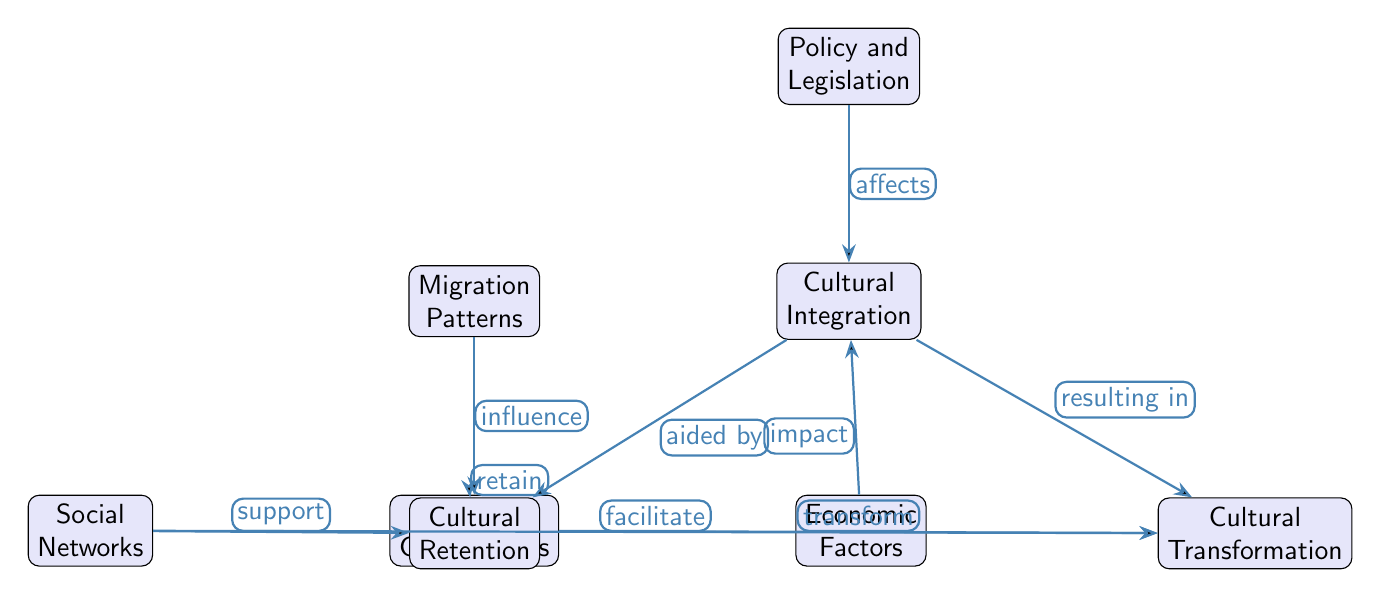What is the primary factor that influences cultural integration? The diagram indicates that migration patterns are the primary factor influencing cultural integration, as represented by the directed edge from "Migration Patterns" to "Cultural Integration."
Answer: Migration Patterns How many nodes are present in the diagram? By counting the distinct labeled boxes in the diagram, there are a total of eight nodes shown.
Answer: 8 What does "Immigrant Communities" do in relation to "Cultural Retention"? The diagram shows that immigrant communities have a direct relationship with cultural retention, indicated by the label "retain" from "Immigrant Communities" to "Cultural Retention."
Answer: retain What influences cultural integration by impacting it directly? "Economic Factors" is shown to have a direct influence on cultural integration, with an edge labeled "impact" leading from "Economic Factors" to "Cultural Integration."
Answer: Economic Factors What role does "Policy and Legislation" play regarding cultural integration? The diagram specifies that policy and legislation affect cultural integration, depicted by the label "affects" from "Policy and Legislation" to "Cultural Integration."
Answer: affects How do social networks support cultural retention? The diagram illustrates that social networks support cultural retention through a directed edge labeled "support," showing a direct relationship from "Social Networks" to "Cultural Retention."
Answer: support What can be said about the transformation of culture in relation to immigrant communities? The diagram indicates that immigrant communities transform culture, with a clearly labeled edge "transform" pointing from "Immigrant Communities" to "Cultural Transformation."
Answer: transform Which component is essential for cultural transformation? The diagram indicates that cultural integration is essential for cultural transformation, with a directed edge showing the relationship "resulting in" between "Cultural Integration" and "Cultural Transformation."
Answer: Cultural Integration How do economic factors relate to cultural integration? The diagram depicts that economic factors have an impact on cultural integration, illustrated by the edge labeled "impact" connecting "Economic Factors" to "Cultural Integration."
Answer: impact 